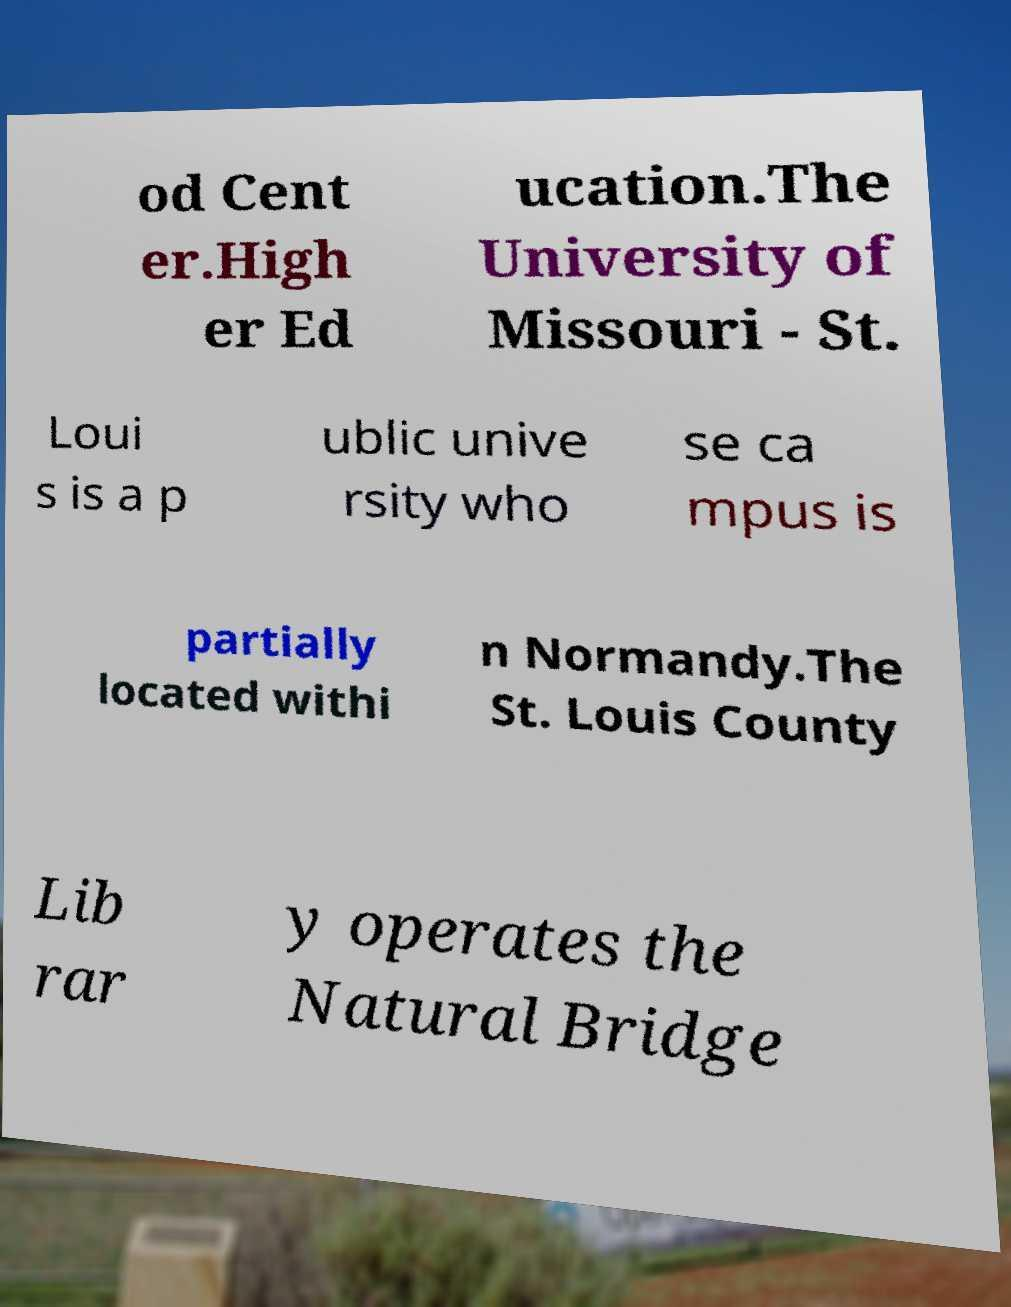Could you assist in decoding the text presented in this image and type it out clearly? od Cent er.High er Ed ucation.The University of Missouri - St. Loui s is a p ublic unive rsity who se ca mpus is partially located withi n Normandy.The St. Louis County Lib rar y operates the Natural Bridge 